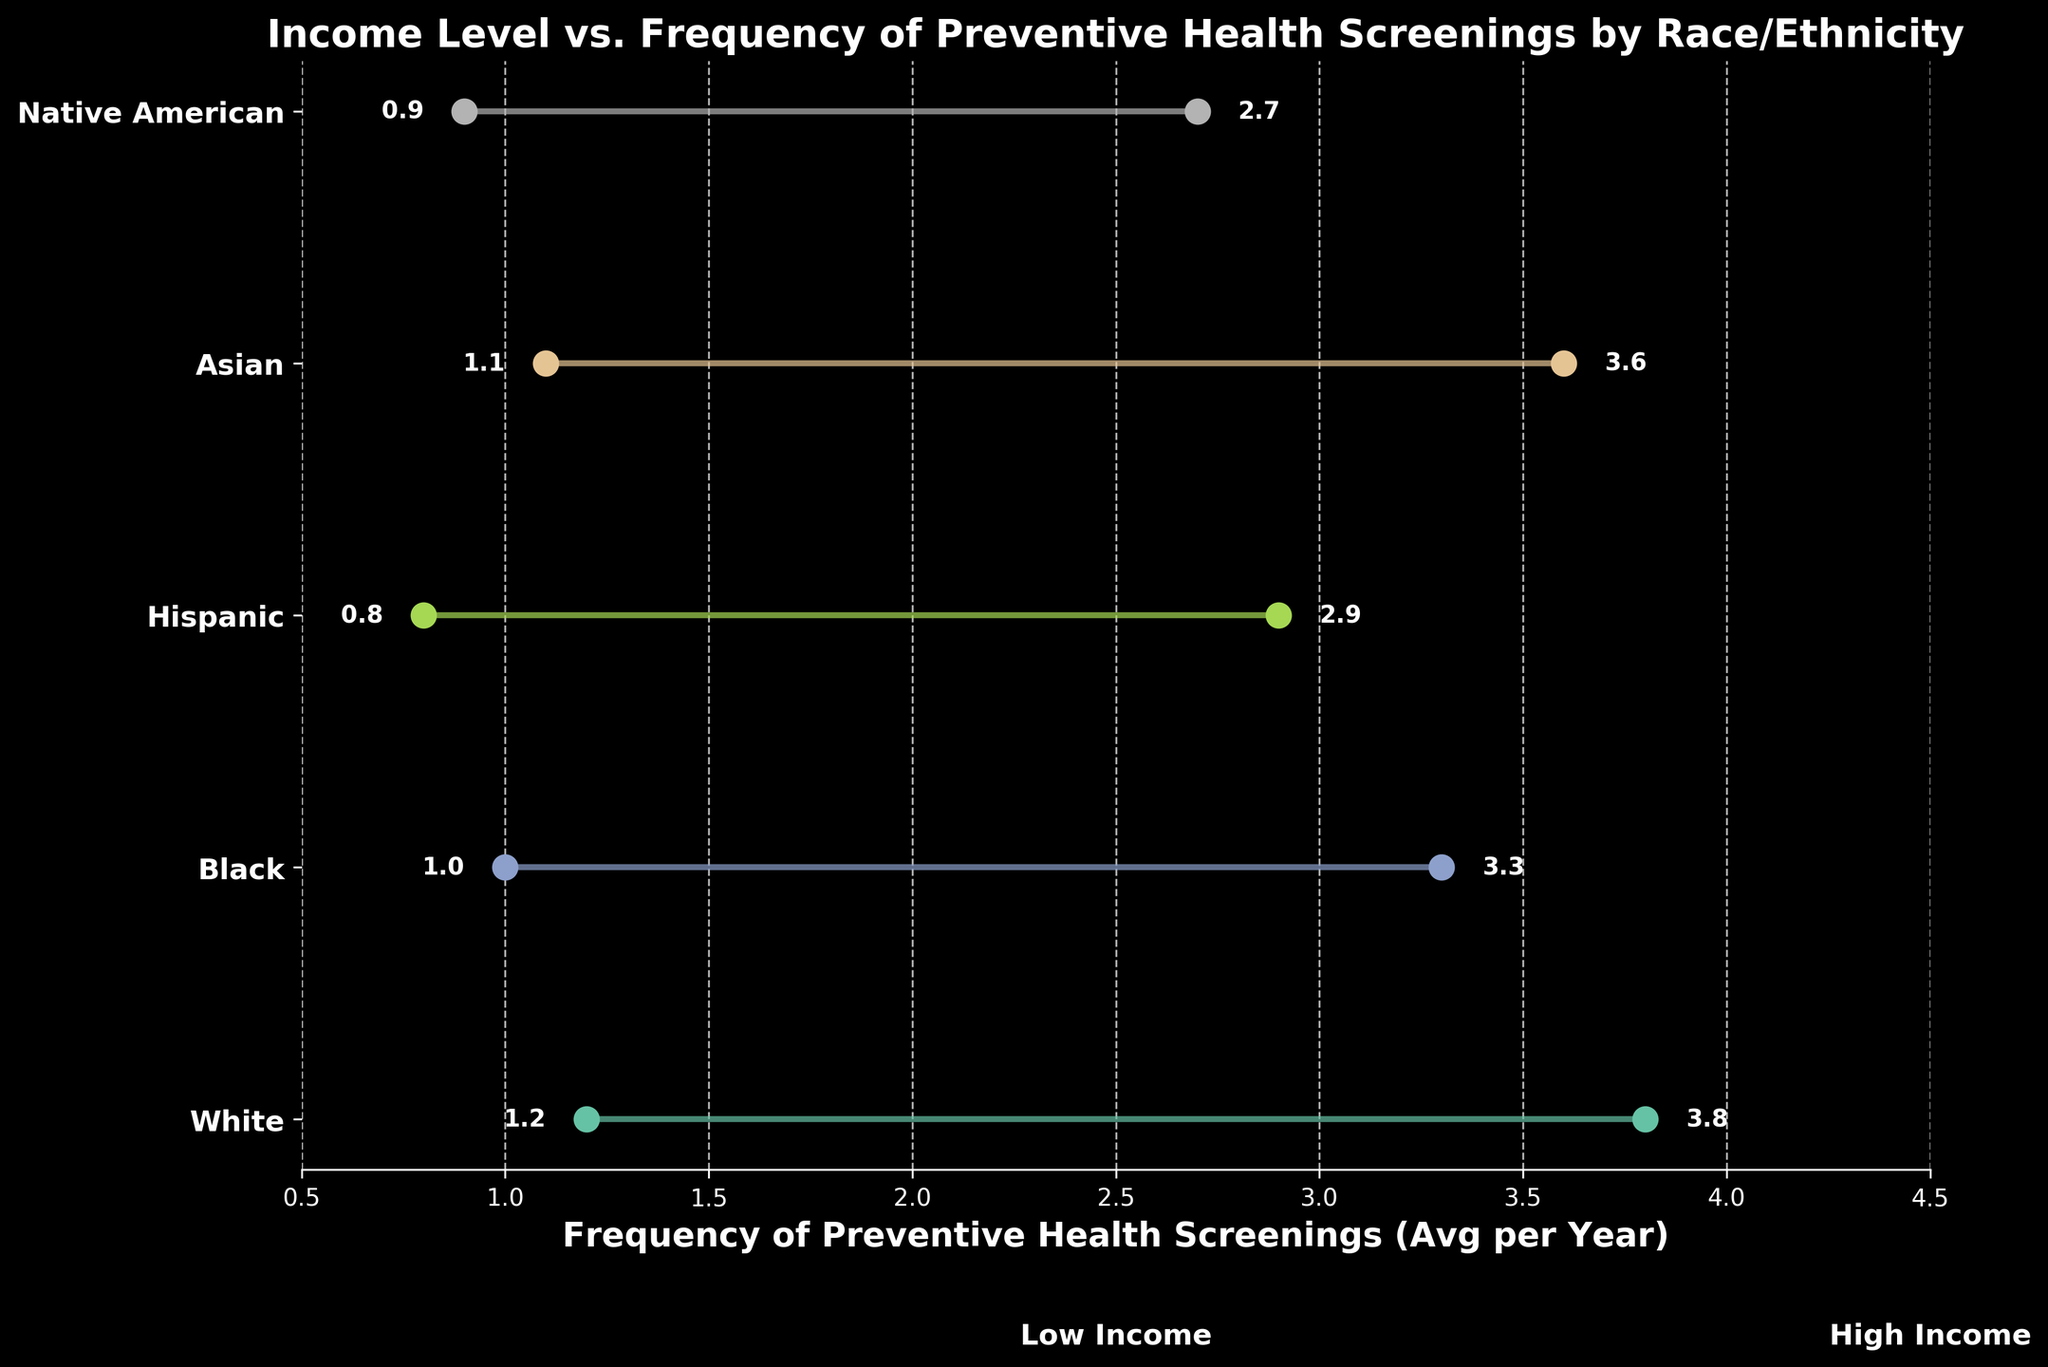What is the average frequency of preventive health screenings for White individuals with middle income? The figure shows the frequency of preventive health screenings by race/ethnicity and income. For White individuals with middle income, the marker is positioned at 2.5 on the x-axis.
Answer: 2.5 How does the frequency of preventive health screenings for Hispanic individuals with high income compare to that of Native American individuals with high income? The frequency of preventive health screenings for Hispanic individuals with high income is 2.9, while for Native American individuals with high income, it is 2.7. Therefore, Hispanic individuals have a slightly higher frequency.
Answer: Hispanic individuals have a slightly higher frequency Which race/ethnicity shows the greatest difference in the frequency of screenings between low and high income levels? By examining the distances between the low and high income points along the x-axis for each race/ethnicity, we can see that White individuals have the greatest difference, with their frequencies ranging from 1.2 to 3.8, a difference of 2.6.
Answer: White What is the frequency of preventive health screenings for Black individuals with middle income? The figure indicates the frequency of preventive health screenings for Black individuals with middle income. The marker for this group is positioned at 2.1 on the x-axis.
Answer: 2.1 How does the frequency for Asian individuals with low income compare to Hispanic individuals with low income? Asian individuals with low income have a frequency marker at 1.1, while Hispanic individuals with low income have a frequency of 0.8. Therefore, Asian individuals have a higher frequency.
Answer: Asian individuals have a higher frequency What is the difference in the frequency of preventive health screenings between low and high income levels for Black individuals? The frequency of preventive health screenings for Black individuals is 1.0 for low income and 3.3 for high income. The difference is calculated as 3.3 - 1.0 = 2.3.
Answer: 2.3 Which race/ethnicity has the lowest frequency of preventive health screenings for middle income individuals? By checking the markers for middle income along the x-axis, Hispanic individuals have the lowest frequency at 1.9.
Answer: Hispanic What is the range of the frequency of preventive health screenings for White individuals across different income levels? For White individuals, the frequencies are 1.2 (low income), 2.5 (middle income), and 3.8 (high income). The range is determined by subtracting the minimum value from the maximum, which is 3.8 - 1.2 = 2.6.
Answer: 2.6 Which race/ethnicity exhibits the smallest difference in screening frequency between low and high income levels? By comparing the differences between low and high income frequencies, Native American individuals have the smallest difference: from 0.9 to 2.7, a difference of 1.8.
Answer: Native American What is the frequency of preventive health screenings for Asian individuals with high income? The figure shows the frequency of preventive health screenings for Asian individuals with high income at 3.6 on the x-axis.
Answer: 3.6 